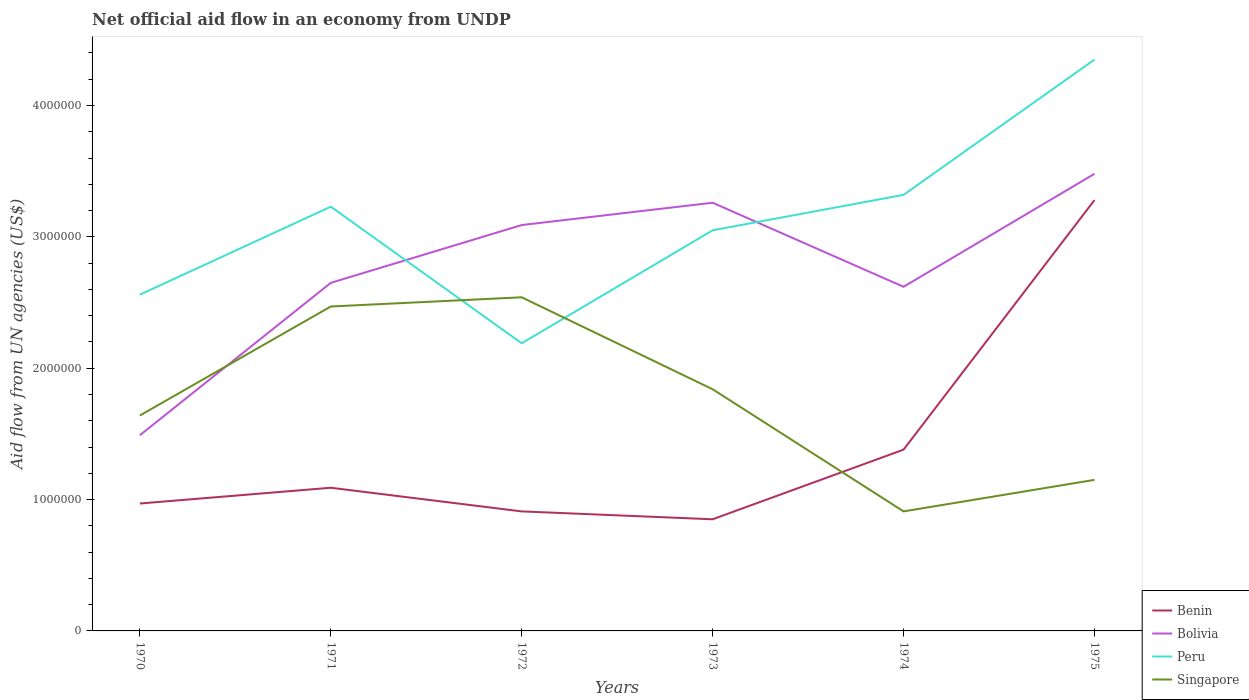How many different coloured lines are there?
Your answer should be very brief. 4. Across all years, what is the maximum net official aid flow in Bolivia?
Give a very brief answer. 1.49e+06. In which year was the net official aid flow in Singapore maximum?
Provide a succinct answer. 1974. What is the total net official aid flow in Benin in the graph?
Your response must be concise. -2.43e+06. What is the difference between the highest and the second highest net official aid flow in Benin?
Your answer should be very brief. 2.43e+06. Is the net official aid flow in Bolivia strictly greater than the net official aid flow in Benin over the years?
Provide a short and direct response. No. How many lines are there?
Make the answer very short. 4. How many years are there in the graph?
Offer a terse response. 6. What is the difference between two consecutive major ticks on the Y-axis?
Offer a very short reply. 1.00e+06. Does the graph contain grids?
Your answer should be compact. No. Where does the legend appear in the graph?
Your answer should be very brief. Bottom right. How are the legend labels stacked?
Offer a very short reply. Vertical. What is the title of the graph?
Your answer should be compact. Net official aid flow in an economy from UNDP. What is the label or title of the X-axis?
Ensure brevity in your answer.  Years. What is the label or title of the Y-axis?
Provide a succinct answer. Aid flow from UN agencies (US$). What is the Aid flow from UN agencies (US$) of Benin in 1970?
Make the answer very short. 9.70e+05. What is the Aid flow from UN agencies (US$) of Bolivia in 1970?
Offer a very short reply. 1.49e+06. What is the Aid flow from UN agencies (US$) of Peru in 1970?
Provide a succinct answer. 2.56e+06. What is the Aid flow from UN agencies (US$) of Singapore in 1970?
Offer a terse response. 1.64e+06. What is the Aid flow from UN agencies (US$) of Benin in 1971?
Your response must be concise. 1.09e+06. What is the Aid flow from UN agencies (US$) in Bolivia in 1971?
Ensure brevity in your answer.  2.65e+06. What is the Aid flow from UN agencies (US$) in Peru in 1971?
Your answer should be compact. 3.23e+06. What is the Aid flow from UN agencies (US$) of Singapore in 1971?
Ensure brevity in your answer.  2.47e+06. What is the Aid flow from UN agencies (US$) of Benin in 1972?
Your answer should be very brief. 9.10e+05. What is the Aid flow from UN agencies (US$) in Bolivia in 1972?
Offer a very short reply. 3.09e+06. What is the Aid flow from UN agencies (US$) in Peru in 1972?
Your answer should be compact. 2.19e+06. What is the Aid flow from UN agencies (US$) of Singapore in 1972?
Give a very brief answer. 2.54e+06. What is the Aid flow from UN agencies (US$) of Benin in 1973?
Your answer should be compact. 8.50e+05. What is the Aid flow from UN agencies (US$) of Bolivia in 1973?
Make the answer very short. 3.26e+06. What is the Aid flow from UN agencies (US$) in Peru in 1973?
Your answer should be very brief. 3.05e+06. What is the Aid flow from UN agencies (US$) in Singapore in 1973?
Make the answer very short. 1.84e+06. What is the Aid flow from UN agencies (US$) in Benin in 1974?
Keep it short and to the point. 1.38e+06. What is the Aid flow from UN agencies (US$) in Bolivia in 1974?
Keep it short and to the point. 2.62e+06. What is the Aid flow from UN agencies (US$) in Peru in 1974?
Your response must be concise. 3.32e+06. What is the Aid flow from UN agencies (US$) in Singapore in 1974?
Your response must be concise. 9.10e+05. What is the Aid flow from UN agencies (US$) of Benin in 1975?
Provide a short and direct response. 3.28e+06. What is the Aid flow from UN agencies (US$) in Bolivia in 1975?
Keep it short and to the point. 3.48e+06. What is the Aid flow from UN agencies (US$) of Peru in 1975?
Provide a succinct answer. 4.35e+06. What is the Aid flow from UN agencies (US$) in Singapore in 1975?
Make the answer very short. 1.15e+06. Across all years, what is the maximum Aid flow from UN agencies (US$) in Benin?
Keep it short and to the point. 3.28e+06. Across all years, what is the maximum Aid flow from UN agencies (US$) of Bolivia?
Ensure brevity in your answer.  3.48e+06. Across all years, what is the maximum Aid flow from UN agencies (US$) of Peru?
Ensure brevity in your answer.  4.35e+06. Across all years, what is the maximum Aid flow from UN agencies (US$) in Singapore?
Your response must be concise. 2.54e+06. Across all years, what is the minimum Aid flow from UN agencies (US$) of Benin?
Provide a succinct answer. 8.50e+05. Across all years, what is the minimum Aid flow from UN agencies (US$) in Bolivia?
Provide a short and direct response. 1.49e+06. Across all years, what is the minimum Aid flow from UN agencies (US$) of Peru?
Ensure brevity in your answer.  2.19e+06. Across all years, what is the minimum Aid flow from UN agencies (US$) in Singapore?
Give a very brief answer. 9.10e+05. What is the total Aid flow from UN agencies (US$) of Benin in the graph?
Provide a short and direct response. 8.48e+06. What is the total Aid flow from UN agencies (US$) in Bolivia in the graph?
Ensure brevity in your answer.  1.66e+07. What is the total Aid flow from UN agencies (US$) of Peru in the graph?
Offer a very short reply. 1.87e+07. What is the total Aid flow from UN agencies (US$) in Singapore in the graph?
Your answer should be compact. 1.06e+07. What is the difference between the Aid flow from UN agencies (US$) in Bolivia in 1970 and that in 1971?
Provide a short and direct response. -1.16e+06. What is the difference between the Aid flow from UN agencies (US$) of Peru in 1970 and that in 1971?
Provide a short and direct response. -6.70e+05. What is the difference between the Aid flow from UN agencies (US$) in Singapore in 1970 and that in 1971?
Offer a terse response. -8.30e+05. What is the difference between the Aid flow from UN agencies (US$) in Benin in 1970 and that in 1972?
Your answer should be compact. 6.00e+04. What is the difference between the Aid flow from UN agencies (US$) of Bolivia in 1970 and that in 1972?
Keep it short and to the point. -1.60e+06. What is the difference between the Aid flow from UN agencies (US$) of Peru in 1970 and that in 1972?
Ensure brevity in your answer.  3.70e+05. What is the difference between the Aid flow from UN agencies (US$) in Singapore in 1970 and that in 1972?
Offer a very short reply. -9.00e+05. What is the difference between the Aid flow from UN agencies (US$) of Benin in 1970 and that in 1973?
Keep it short and to the point. 1.20e+05. What is the difference between the Aid flow from UN agencies (US$) in Bolivia in 1970 and that in 1973?
Make the answer very short. -1.77e+06. What is the difference between the Aid flow from UN agencies (US$) of Peru in 1970 and that in 1973?
Give a very brief answer. -4.90e+05. What is the difference between the Aid flow from UN agencies (US$) in Singapore in 1970 and that in 1973?
Your answer should be compact. -2.00e+05. What is the difference between the Aid flow from UN agencies (US$) in Benin in 1970 and that in 1974?
Offer a very short reply. -4.10e+05. What is the difference between the Aid flow from UN agencies (US$) in Bolivia in 1970 and that in 1974?
Your answer should be very brief. -1.13e+06. What is the difference between the Aid flow from UN agencies (US$) of Peru in 1970 and that in 1974?
Your response must be concise. -7.60e+05. What is the difference between the Aid flow from UN agencies (US$) in Singapore in 1970 and that in 1974?
Your answer should be very brief. 7.30e+05. What is the difference between the Aid flow from UN agencies (US$) of Benin in 1970 and that in 1975?
Give a very brief answer. -2.31e+06. What is the difference between the Aid flow from UN agencies (US$) of Bolivia in 1970 and that in 1975?
Give a very brief answer. -1.99e+06. What is the difference between the Aid flow from UN agencies (US$) of Peru in 1970 and that in 1975?
Make the answer very short. -1.79e+06. What is the difference between the Aid flow from UN agencies (US$) of Benin in 1971 and that in 1972?
Your answer should be compact. 1.80e+05. What is the difference between the Aid flow from UN agencies (US$) of Bolivia in 1971 and that in 1972?
Provide a short and direct response. -4.40e+05. What is the difference between the Aid flow from UN agencies (US$) in Peru in 1971 and that in 1972?
Offer a very short reply. 1.04e+06. What is the difference between the Aid flow from UN agencies (US$) in Singapore in 1971 and that in 1972?
Your response must be concise. -7.00e+04. What is the difference between the Aid flow from UN agencies (US$) of Bolivia in 1971 and that in 1973?
Offer a very short reply. -6.10e+05. What is the difference between the Aid flow from UN agencies (US$) of Singapore in 1971 and that in 1973?
Your answer should be very brief. 6.30e+05. What is the difference between the Aid flow from UN agencies (US$) in Bolivia in 1971 and that in 1974?
Provide a short and direct response. 3.00e+04. What is the difference between the Aid flow from UN agencies (US$) of Peru in 1971 and that in 1974?
Provide a short and direct response. -9.00e+04. What is the difference between the Aid flow from UN agencies (US$) of Singapore in 1971 and that in 1974?
Provide a succinct answer. 1.56e+06. What is the difference between the Aid flow from UN agencies (US$) in Benin in 1971 and that in 1975?
Provide a short and direct response. -2.19e+06. What is the difference between the Aid flow from UN agencies (US$) of Bolivia in 1971 and that in 1975?
Your response must be concise. -8.30e+05. What is the difference between the Aid flow from UN agencies (US$) in Peru in 1971 and that in 1975?
Provide a succinct answer. -1.12e+06. What is the difference between the Aid flow from UN agencies (US$) of Singapore in 1971 and that in 1975?
Give a very brief answer. 1.32e+06. What is the difference between the Aid flow from UN agencies (US$) of Benin in 1972 and that in 1973?
Make the answer very short. 6.00e+04. What is the difference between the Aid flow from UN agencies (US$) in Bolivia in 1972 and that in 1973?
Your answer should be compact. -1.70e+05. What is the difference between the Aid flow from UN agencies (US$) in Peru in 1972 and that in 1973?
Offer a terse response. -8.60e+05. What is the difference between the Aid flow from UN agencies (US$) of Benin in 1972 and that in 1974?
Provide a succinct answer. -4.70e+05. What is the difference between the Aid flow from UN agencies (US$) of Bolivia in 1972 and that in 1974?
Provide a short and direct response. 4.70e+05. What is the difference between the Aid flow from UN agencies (US$) of Peru in 1972 and that in 1974?
Provide a short and direct response. -1.13e+06. What is the difference between the Aid flow from UN agencies (US$) in Singapore in 1972 and that in 1974?
Make the answer very short. 1.63e+06. What is the difference between the Aid flow from UN agencies (US$) of Benin in 1972 and that in 1975?
Provide a succinct answer. -2.37e+06. What is the difference between the Aid flow from UN agencies (US$) of Bolivia in 1972 and that in 1975?
Provide a short and direct response. -3.90e+05. What is the difference between the Aid flow from UN agencies (US$) of Peru in 1972 and that in 1975?
Give a very brief answer. -2.16e+06. What is the difference between the Aid flow from UN agencies (US$) in Singapore in 1972 and that in 1975?
Keep it short and to the point. 1.39e+06. What is the difference between the Aid flow from UN agencies (US$) in Benin in 1973 and that in 1974?
Ensure brevity in your answer.  -5.30e+05. What is the difference between the Aid flow from UN agencies (US$) of Bolivia in 1973 and that in 1974?
Keep it short and to the point. 6.40e+05. What is the difference between the Aid flow from UN agencies (US$) of Peru in 1973 and that in 1974?
Provide a succinct answer. -2.70e+05. What is the difference between the Aid flow from UN agencies (US$) in Singapore in 1973 and that in 1974?
Ensure brevity in your answer.  9.30e+05. What is the difference between the Aid flow from UN agencies (US$) of Benin in 1973 and that in 1975?
Offer a very short reply. -2.43e+06. What is the difference between the Aid flow from UN agencies (US$) in Bolivia in 1973 and that in 1975?
Keep it short and to the point. -2.20e+05. What is the difference between the Aid flow from UN agencies (US$) in Peru in 1973 and that in 1975?
Your answer should be very brief. -1.30e+06. What is the difference between the Aid flow from UN agencies (US$) in Singapore in 1973 and that in 1975?
Offer a very short reply. 6.90e+05. What is the difference between the Aid flow from UN agencies (US$) in Benin in 1974 and that in 1975?
Your answer should be compact. -1.90e+06. What is the difference between the Aid flow from UN agencies (US$) of Bolivia in 1974 and that in 1975?
Ensure brevity in your answer.  -8.60e+05. What is the difference between the Aid flow from UN agencies (US$) of Peru in 1974 and that in 1975?
Ensure brevity in your answer.  -1.03e+06. What is the difference between the Aid flow from UN agencies (US$) in Singapore in 1974 and that in 1975?
Your answer should be compact. -2.40e+05. What is the difference between the Aid flow from UN agencies (US$) of Benin in 1970 and the Aid flow from UN agencies (US$) of Bolivia in 1971?
Your answer should be very brief. -1.68e+06. What is the difference between the Aid flow from UN agencies (US$) of Benin in 1970 and the Aid flow from UN agencies (US$) of Peru in 1971?
Offer a terse response. -2.26e+06. What is the difference between the Aid flow from UN agencies (US$) of Benin in 1970 and the Aid flow from UN agencies (US$) of Singapore in 1971?
Your response must be concise. -1.50e+06. What is the difference between the Aid flow from UN agencies (US$) in Bolivia in 1970 and the Aid flow from UN agencies (US$) in Peru in 1971?
Offer a very short reply. -1.74e+06. What is the difference between the Aid flow from UN agencies (US$) of Bolivia in 1970 and the Aid flow from UN agencies (US$) of Singapore in 1971?
Your answer should be very brief. -9.80e+05. What is the difference between the Aid flow from UN agencies (US$) in Benin in 1970 and the Aid flow from UN agencies (US$) in Bolivia in 1972?
Offer a very short reply. -2.12e+06. What is the difference between the Aid flow from UN agencies (US$) in Benin in 1970 and the Aid flow from UN agencies (US$) in Peru in 1972?
Offer a terse response. -1.22e+06. What is the difference between the Aid flow from UN agencies (US$) of Benin in 1970 and the Aid flow from UN agencies (US$) of Singapore in 1972?
Your answer should be compact. -1.57e+06. What is the difference between the Aid flow from UN agencies (US$) of Bolivia in 1970 and the Aid flow from UN agencies (US$) of Peru in 1972?
Your response must be concise. -7.00e+05. What is the difference between the Aid flow from UN agencies (US$) of Bolivia in 1970 and the Aid flow from UN agencies (US$) of Singapore in 1972?
Give a very brief answer. -1.05e+06. What is the difference between the Aid flow from UN agencies (US$) of Benin in 1970 and the Aid flow from UN agencies (US$) of Bolivia in 1973?
Keep it short and to the point. -2.29e+06. What is the difference between the Aid flow from UN agencies (US$) in Benin in 1970 and the Aid flow from UN agencies (US$) in Peru in 1973?
Your answer should be compact. -2.08e+06. What is the difference between the Aid flow from UN agencies (US$) of Benin in 1970 and the Aid flow from UN agencies (US$) of Singapore in 1973?
Offer a very short reply. -8.70e+05. What is the difference between the Aid flow from UN agencies (US$) in Bolivia in 1970 and the Aid flow from UN agencies (US$) in Peru in 1973?
Make the answer very short. -1.56e+06. What is the difference between the Aid flow from UN agencies (US$) in Bolivia in 1970 and the Aid flow from UN agencies (US$) in Singapore in 1973?
Your answer should be compact. -3.50e+05. What is the difference between the Aid flow from UN agencies (US$) of Peru in 1970 and the Aid flow from UN agencies (US$) of Singapore in 1973?
Ensure brevity in your answer.  7.20e+05. What is the difference between the Aid flow from UN agencies (US$) of Benin in 1970 and the Aid flow from UN agencies (US$) of Bolivia in 1974?
Your response must be concise. -1.65e+06. What is the difference between the Aid flow from UN agencies (US$) of Benin in 1970 and the Aid flow from UN agencies (US$) of Peru in 1974?
Your answer should be very brief. -2.35e+06. What is the difference between the Aid flow from UN agencies (US$) in Benin in 1970 and the Aid flow from UN agencies (US$) in Singapore in 1974?
Ensure brevity in your answer.  6.00e+04. What is the difference between the Aid flow from UN agencies (US$) in Bolivia in 1970 and the Aid flow from UN agencies (US$) in Peru in 1974?
Your answer should be compact. -1.83e+06. What is the difference between the Aid flow from UN agencies (US$) in Bolivia in 1970 and the Aid flow from UN agencies (US$) in Singapore in 1974?
Offer a very short reply. 5.80e+05. What is the difference between the Aid flow from UN agencies (US$) in Peru in 1970 and the Aid flow from UN agencies (US$) in Singapore in 1974?
Offer a very short reply. 1.65e+06. What is the difference between the Aid flow from UN agencies (US$) in Benin in 1970 and the Aid flow from UN agencies (US$) in Bolivia in 1975?
Provide a succinct answer. -2.51e+06. What is the difference between the Aid flow from UN agencies (US$) in Benin in 1970 and the Aid flow from UN agencies (US$) in Peru in 1975?
Provide a succinct answer. -3.38e+06. What is the difference between the Aid flow from UN agencies (US$) in Benin in 1970 and the Aid flow from UN agencies (US$) in Singapore in 1975?
Offer a very short reply. -1.80e+05. What is the difference between the Aid flow from UN agencies (US$) of Bolivia in 1970 and the Aid flow from UN agencies (US$) of Peru in 1975?
Your answer should be very brief. -2.86e+06. What is the difference between the Aid flow from UN agencies (US$) of Peru in 1970 and the Aid flow from UN agencies (US$) of Singapore in 1975?
Keep it short and to the point. 1.41e+06. What is the difference between the Aid flow from UN agencies (US$) in Benin in 1971 and the Aid flow from UN agencies (US$) in Bolivia in 1972?
Your response must be concise. -2.00e+06. What is the difference between the Aid flow from UN agencies (US$) in Benin in 1971 and the Aid flow from UN agencies (US$) in Peru in 1972?
Keep it short and to the point. -1.10e+06. What is the difference between the Aid flow from UN agencies (US$) of Benin in 1971 and the Aid flow from UN agencies (US$) of Singapore in 1972?
Make the answer very short. -1.45e+06. What is the difference between the Aid flow from UN agencies (US$) in Bolivia in 1971 and the Aid flow from UN agencies (US$) in Singapore in 1972?
Your answer should be very brief. 1.10e+05. What is the difference between the Aid flow from UN agencies (US$) of Peru in 1971 and the Aid flow from UN agencies (US$) of Singapore in 1972?
Ensure brevity in your answer.  6.90e+05. What is the difference between the Aid flow from UN agencies (US$) of Benin in 1971 and the Aid flow from UN agencies (US$) of Bolivia in 1973?
Provide a short and direct response. -2.17e+06. What is the difference between the Aid flow from UN agencies (US$) of Benin in 1971 and the Aid flow from UN agencies (US$) of Peru in 1973?
Ensure brevity in your answer.  -1.96e+06. What is the difference between the Aid flow from UN agencies (US$) of Benin in 1971 and the Aid flow from UN agencies (US$) of Singapore in 1973?
Give a very brief answer. -7.50e+05. What is the difference between the Aid flow from UN agencies (US$) of Bolivia in 1971 and the Aid flow from UN agencies (US$) of Peru in 1973?
Offer a very short reply. -4.00e+05. What is the difference between the Aid flow from UN agencies (US$) of Bolivia in 1971 and the Aid flow from UN agencies (US$) of Singapore in 1973?
Your answer should be very brief. 8.10e+05. What is the difference between the Aid flow from UN agencies (US$) of Peru in 1971 and the Aid flow from UN agencies (US$) of Singapore in 1973?
Provide a succinct answer. 1.39e+06. What is the difference between the Aid flow from UN agencies (US$) in Benin in 1971 and the Aid flow from UN agencies (US$) in Bolivia in 1974?
Provide a succinct answer. -1.53e+06. What is the difference between the Aid flow from UN agencies (US$) of Benin in 1971 and the Aid flow from UN agencies (US$) of Peru in 1974?
Your response must be concise. -2.23e+06. What is the difference between the Aid flow from UN agencies (US$) in Benin in 1971 and the Aid flow from UN agencies (US$) in Singapore in 1974?
Your answer should be very brief. 1.80e+05. What is the difference between the Aid flow from UN agencies (US$) in Bolivia in 1971 and the Aid flow from UN agencies (US$) in Peru in 1974?
Provide a succinct answer. -6.70e+05. What is the difference between the Aid flow from UN agencies (US$) in Bolivia in 1971 and the Aid flow from UN agencies (US$) in Singapore in 1974?
Your response must be concise. 1.74e+06. What is the difference between the Aid flow from UN agencies (US$) in Peru in 1971 and the Aid flow from UN agencies (US$) in Singapore in 1974?
Give a very brief answer. 2.32e+06. What is the difference between the Aid flow from UN agencies (US$) of Benin in 1971 and the Aid flow from UN agencies (US$) of Bolivia in 1975?
Offer a terse response. -2.39e+06. What is the difference between the Aid flow from UN agencies (US$) of Benin in 1971 and the Aid flow from UN agencies (US$) of Peru in 1975?
Your answer should be compact. -3.26e+06. What is the difference between the Aid flow from UN agencies (US$) in Benin in 1971 and the Aid flow from UN agencies (US$) in Singapore in 1975?
Your response must be concise. -6.00e+04. What is the difference between the Aid flow from UN agencies (US$) of Bolivia in 1971 and the Aid flow from UN agencies (US$) of Peru in 1975?
Your answer should be very brief. -1.70e+06. What is the difference between the Aid flow from UN agencies (US$) in Bolivia in 1971 and the Aid flow from UN agencies (US$) in Singapore in 1975?
Your response must be concise. 1.50e+06. What is the difference between the Aid flow from UN agencies (US$) in Peru in 1971 and the Aid flow from UN agencies (US$) in Singapore in 1975?
Keep it short and to the point. 2.08e+06. What is the difference between the Aid flow from UN agencies (US$) of Benin in 1972 and the Aid flow from UN agencies (US$) of Bolivia in 1973?
Give a very brief answer. -2.35e+06. What is the difference between the Aid flow from UN agencies (US$) of Benin in 1972 and the Aid flow from UN agencies (US$) of Peru in 1973?
Give a very brief answer. -2.14e+06. What is the difference between the Aid flow from UN agencies (US$) in Benin in 1972 and the Aid flow from UN agencies (US$) in Singapore in 1973?
Your answer should be compact. -9.30e+05. What is the difference between the Aid flow from UN agencies (US$) of Bolivia in 1972 and the Aid flow from UN agencies (US$) of Peru in 1973?
Keep it short and to the point. 4.00e+04. What is the difference between the Aid flow from UN agencies (US$) in Bolivia in 1972 and the Aid flow from UN agencies (US$) in Singapore in 1973?
Your answer should be compact. 1.25e+06. What is the difference between the Aid flow from UN agencies (US$) in Benin in 1972 and the Aid flow from UN agencies (US$) in Bolivia in 1974?
Keep it short and to the point. -1.71e+06. What is the difference between the Aid flow from UN agencies (US$) in Benin in 1972 and the Aid flow from UN agencies (US$) in Peru in 1974?
Offer a very short reply. -2.41e+06. What is the difference between the Aid flow from UN agencies (US$) in Benin in 1972 and the Aid flow from UN agencies (US$) in Singapore in 1974?
Your answer should be very brief. 0. What is the difference between the Aid flow from UN agencies (US$) in Bolivia in 1972 and the Aid flow from UN agencies (US$) in Peru in 1974?
Keep it short and to the point. -2.30e+05. What is the difference between the Aid flow from UN agencies (US$) in Bolivia in 1972 and the Aid flow from UN agencies (US$) in Singapore in 1974?
Ensure brevity in your answer.  2.18e+06. What is the difference between the Aid flow from UN agencies (US$) in Peru in 1972 and the Aid flow from UN agencies (US$) in Singapore in 1974?
Ensure brevity in your answer.  1.28e+06. What is the difference between the Aid flow from UN agencies (US$) of Benin in 1972 and the Aid flow from UN agencies (US$) of Bolivia in 1975?
Your response must be concise. -2.57e+06. What is the difference between the Aid flow from UN agencies (US$) of Benin in 1972 and the Aid flow from UN agencies (US$) of Peru in 1975?
Provide a short and direct response. -3.44e+06. What is the difference between the Aid flow from UN agencies (US$) of Benin in 1972 and the Aid flow from UN agencies (US$) of Singapore in 1975?
Offer a very short reply. -2.40e+05. What is the difference between the Aid flow from UN agencies (US$) of Bolivia in 1972 and the Aid flow from UN agencies (US$) of Peru in 1975?
Keep it short and to the point. -1.26e+06. What is the difference between the Aid flow from UN agencies (US$) in Bolivia in 1972 and the Aid flow from UN agencies (US$) in Singapore in 1975?
Your answer should be very brief. 1.94e+06. What is the difference between the Aid flow from UN agencies (US$) in Peru in 1972 and the Aid flow from UN agencies (US$) in Singapore in 1975?
Provide a succinct answer. 1.04e+06. What is the difference between the Aid flow from UN agencies (US$) in Benin in 1973 and the Aid flow from UN agencies (US$) in Bolivia in 1974?
Offer a terse response. -1.77e+06. What is the difference between the Aid flow from UN agencies (US$) in Benin in 1973 and the Aid flow from UN agencies (US$) in Peru in 1974?
Offer a terse response. -2.47e+06. What is the difference between the Aid flow from UN agencies (US$) of Benin in 1973 and the Aid flow from UN agencies (US$) of Singapore in 1974?
Make the answer very short. -6.00e+04. What is the difference between the Aid flow from UN agencies (US$) of Bolivia in 1973 and the Aid flow from UN agencies (US$) of Singapore in 1974?
Keep it short and to the point. 2.35e+06. What is the difference between the Aid flow from UN agencies (US$) in Peru in 1973 and the Aid flow from UN agencies (US$) in Singapore in 1974?
Your answer should be very brief. 2.14e+06. What is the difference between the Aid flow from UN agencies (US$) of Benin in 1973 and the Aid flow from UN agencies (US$) of Bolivia in 1975?
Your response must be concise. -2.63e+06. What is the difference between the Aid flow from UN agencies (US$) of Benin in 1973 and the Aid flow from UN agencies (US$) of Peru in 1975?
Provide a succinct answer. -3.50e+06. What is the difference between the Aid flow from UN agencies (US$) in Bolivia in 1973 and the Aid flow from UN agencies (US$) in Peru in 1975?
Provide a succinct answer. -1.09e+06. What is the difference between the Aid flow from UN agencies (US$) of Bolivia in 1973 and the Aid flow from UN agencies (US$) of Singapore in 1975?
Your response must be concise. 2.11e+06. What is the difference between the Aid flow from UN agencies (US$) of Peru in 1973 and the Aid flow from UN agencies (US$) of Singapore in 1975?
Offer a very short reply. 1.90e+06. What is the difference between the Aid flow from UN agencies (US$) of Benin in 1974 and the Aid flow from UN agencies (US$) of Bolivia in 1975?
Offer a terse response. -2.10e+06. What is the difference between the Aid flow from UN agencies (US$) in Benin in 1974 and the Aid flow from UN agencies (US$) in Peru in 1975?
Your response must be concise. -2.97e+06. What is the difference between the Aid flow from UN agencies (US$) in Bolivia in 1974 and the Aid flow from UN agencies (US$) in Peru in 1975?
Your response must be concise. -1.73e+06. What is the difference between the Aid flow from UN agencies (US$) of Bolivia in 1974 and the Aid flow from UN agencies (US$) of Singapore in 1975?
Provide a short and direct response. 1.47e+06. What is the difference between the Aid flow from UN agencies (US$) of Peru in 1974 and the Aid flow from UN agencies (US$) of Singapore in 1975?
Your response must be concise. 2.17e+06. What is the average Aid flow from UN agencies (US$) in Benin per year?
Keep it short and to the point. 1.41e+06. What is the average Aid flow from UN agencies (US$) of Bolivia per year?
Offer a terse response. 2.76e+06. What is the average Aid flow from UN agencies (US$) in Peru per year?
Your response must be concise. 3.12e+06. What is the average Aid flow from UN agencies (US$) in Singapore per year?
Give a very brief answer. 1.76e+06. In the year 1970, what is the difference between the Aid flow from UN agencies (US$) in Benin and Aid flow from UN agencies (US$) in Bolivia?
Your response must be concise. -5.20e+05. In the year 1970, what is the difference between the Aid flow from UN agencies (US$) of Benin and Aid flow from UN agencies (US$) of Peru?
Your answer should be very brief. -1.59e+06. In the year 1970, what is the difference between the Aid flow from UN agencies (US$) of Benin and Aid flow from UN agencies (US$) of Singapore?
Provide a succinct answer. -6.70e+05. In the year 1970, what is the difference between the Aid flow from UN agencies (US$) of Bolivia and Aid flow from UN agencies (US$) of Peru?
Offer a very short reply. -1.07e+06. In the year 1970, what is the difference between the Aid flow from UN agencies (US$) in Peru and Aid flow from UN agencies (US$) in Singapore?
Your answer should be very brief. 9.20e+05. In the year 1971, what is the difference between the Aid flow from UN agencies (US$) of Benin and Aid flow from UN agencies (US$) of Bolivia?
Offer a terse response. -1.56e+06. In the year 1971, what is the difference between the Aid flow from UN agencies (US$) of Benin and Aid flow from UN agencies (US$) of Peru?
Ensure brevity in your answer.  -2.14e+06. In the year 1971, what is the difference between the Aid flow from UN agencies (US$) in Benin and Aid flow from UN agencies (US$) in Singapore?
Provide a short and direct response. -1.38e+06. In the year 1971, what is the difference between the Aid flow from UN agencies (US$) of Bolivia and Aid flow from UN agencies (US$) of Peru?
Your answer should be very brief. -5.80e+05. In the year 1971, what is the difference between the Aid flow from UN agencies (US$) of Peru and Aid flow from UN agencies (US$) of Singapore?
Make the answer very short. 7.60e+05. In the year 1972, what is the difference between the Aid flow from UN agencies (US$) of Benin and Aid flow from UN agencies (US$) of Bolivia?
Provide a succinct answer. -2.18e+06. In the year 1972, what is the difference between the Aid flow from UN agencies (US$) in Benin and Aid flow from UN agencies (US$) in Peru?
Make the answer very short. -1.28e+06. In the year 1972, what is the difference between the Aid flow from UN agencies (US$) in Benin and Aid flow from UN agencies (US$) in Singapore?
Ensure brevity in your answer.  -1.63e+06. In the year 1972, what is the difference between the Aid flow from UN agencies (US$) of Bolivia and Aid flow from UN agencies (US$) of Singapore?
Give a very brief answer. 5.50e+05. In the year 1972, what is the difference between the Aid flow from UN agencies (US$) in Peru and Aid flow from UN agencies (US$) in Singapore?
Ensure brevity in your answer.  -3.50e+05. In the year 1973, what is the difference between the Aid flow from UN agencies (US$) in Benin and Aid flow from UN agencies (US$) in Bolivia?
Ensure brevity in your answer.  -2.41e+06. In the year 1973, what is the difference between the Aid flow from UN agencies (US$) of Benin and Aid flow from UN agencies (US$) of Peru?
Provide a short and direct response. -2.20e+06. In the year 1973, what is the difference between the Aid flow from UN agencies (US$) in Benin and Aid flow from UN agencies (US$) in Singapore?
Provide a short and direct response. -9.90e+05. In the year 1973, what is the difference between the Aid flow from UN agencies (US$) of Bolivia and Aid flow from UN agencies (US$) of Peru?
Your response must be concise. 2.10e+05. In the year 1973, what is the difference between the Aid flow from UN agencies (US$) of Bolivia and Aid flow from UN agencies (US$) of Singapore?
Provide a short and direct response. 1.42e+06. In the year 1973, what is the difference between the Aid flow from UN agencies (US$) of Peru and Aid flow from UN agencies (US$) of Singapore?
Provide a short and direct response. 1.21e+06. In the year 1974, what is the difference between the Aid flow from UN agencies (US$) of Benin and Aid flow from UN agencies (US$) of Bolivia?
Your response must be concise. -1.24e+06. In the year 1974, what is the difference between the Aid flow from UN agencies (US$) of Benin and Aid flow from UN agencies (US$) of Peru?
Ensure brevity in your answer.  -1.94e+06. In the year 1974, what is the difference between the Aid flow from UN agencies (US$) in Bolivia and Aid flow from UN agencies (US$) in Peru?
Give a very brief answer. -7.00e+05. In the year 1974, what is the difference between the Aid flow from UN agencies (US$) of Bolivia and Aid flow from UN agencies (US$) of Singapore?
Ensure brevity in your answer.  1.71e+06. In the year 1974, what is the difference between the Aid flow from UN agencies (US$) in Peru and Aid flow from UN agencies (US$) in Singapore?
Ensure brevity in your answer.  2.41e+06. In the year 1975, what is the difference between the Aid flow from UN agencies (US$) in Benin and Aid flow from UN agencies (US$) in Bolivia?
Provide a succinct answer. -2.00e+05. In the year 1975, what is the difference between the Aid flow from UN agencies (US$) in Benin and Aid flow from UN agencies (US$) in Peru?
Ensure brevity in your answer.  -1.07e+06. In the year 1975, what is the difference between the Aid flow from UN agencies (US$) in Benin and Aid flow from UN agencies (US$) in Singapore?
Your answer should be compact. 2.13e+06. In the year 1975, what is the difference between the Aid flow from UN agencies (US$) in Bolivia and Aid flow from UN agencies (US$) in Peru?
Keep it short and to the point. -8.70e+05. In the year 1975, what is the difference between the Aid flow from UN agencies (US$) in Bolivia and Aid flow from UN agencies (US$) in Singapore?
Provide a succinct answer. 2.33e+06. In the year 1975, what is the difference between the Aid flow from UN agencies (US$) of Peru and Aid flow from UN agencies (US$) of Singapore?
Your response must be concise. 3.20e+06. What is the ratio of the Aid flow from UN agencies (US$) of Benin in 1970 to that in 1971?
Your response must be concise. 0.89. What is the ratio of the Aid flow from UN agencies (US$) of Bolivia in 1970 to that in 1971?
Provide a succinct answer. 0.56. What is the ratio of the Aid flow from UN agencies (US$) of Peru in 1970 to that in 1971?
Offer a terse response. 0.79. What is the ratio of the Aid flow from UN agencies (US$) of Singapore in 1970 to that in 1971?
Provide a succinct answer. 0.66. What is the ratio of the Aid flow from UN agencies (US$) of Benin in 1970 to that in 1972?
Offer a very short reply. 1.07. What is the ratio of the Aid flow from UN agencies (US$) of Bolivia in 1970 to that in 1972?
Provide a short and direct response. 0.48. What is the ratio of the Aid flow from UN agencies (US$) in Peru in 1970 to that in 1972?
Your answer should be very brief. 1.17. What is the ratio of the Aid flow from UN agencies (US$) in Singapore in 1970 to that in 1972?
Offer a very short reply. 0.65. What is the ratio of the Aid flow from UN agencies (US$) in Benin in 1970 to that in 1973?
Offer a very short reply. 1.14. What is the ratio of the Aid flow from UN agencies (US$) of Bolivia in 1970 to that in 1973?
Ensure brevity in your answer.  0.46. What is the ratio of the Aid flow from UN agencies (US$) in Peru in 1970 to that in 1973?
Provide a short and direct response. 0.84. What is the ratio of the Aid flow from UN agencies (US$) of Singapore in 1970 to that in 1973?
Provide a short and direct response. 0.89. What is the ratio of the Aid flow from UN agencies (US$) in Benin in 1970 to that in 1974?
Provide a short and direct response. 0.7. What is the ratio of the Aid flow from UN agencies (US$) of Bolivia in 1970 to that in 1974?
Offer a terse response. 0.57. What is the ratio of the Aid flow from UN agencies (US$) in Peru in 1970 to that in 1974?
Provide a short and direct response. 0.77. What is the ratio of the Aid flow from UN agencies (US$) in Singapore in 1970 to that in 1974?
Give a very brief answer. 1.8. What is the ratio of the Aid flow from UN agencies (US$) of Benin in 1970 to that in 1975?
Your answer should be compact. 0.3. What is the ratio of the Aid flow from UN agencies (US$) of Bolivia in 1970 to that in 1975?
Your response must be concise. 0.43. What is the ratio of the Aid flow from UN agencies (US$) of Peru in 1970 to that in 1975?
Give a very brief answer. 0.59. What is the ratio of the Aid flow from UN agencies (US$) of Singapore in 1970 to that in 1975?
Provide a succinct answer. 1.43. What is the ratio of the Aid flow from UN agencies (US$) in Benin in 1971 to that in 1972?
Ensure brevity in your answer.  1.2. What is the ratio of the Aid flow from UN agencies (US$) of Bolivia in 1971 to that in 1972?
Provide a succinct answer. 0.86. What is the ratio of the Aid flow from UN agencies (US$) of Peru in 1971 to that in 1972?
Provide a succinct answer. 1.47. What is the ratio of the Aid flow from UN agencies (US$) in Singapore in 1971 to that in 1972?
Offer a terse response. 0.97. What is the ratio of the Aid flow from UN agencies (US$) in Benin in 1971 to that in 1973?
Your answer should be compact. 1.28. What is the ratio of the Aid flow from UN agencies (US$) in Bolivia in 1971 to that in 1973?
Make the answer very short. 0.81. What is the ratio of the Aid flow from UN agencies (US$) in Peru in 1971 to that in 1973?
Your response must be concise. 1.06. What is the ratio of the Aid flow from UN agencies (US$) of Singapore in 1971 to that in 1973?
Your answer should be compact. 1.34. What is the ratio of the Aid flow from UN agencies (US$) in Benin in 1971 to that in 1974?
Provide a short and direct response. 0.79. What is the ratio of the Aid flow from UN agencies (US$) in Bolivia in 1971 to that in 1974?
Offer a terse response. 1.01. What is the ratio of the Aid flow from UN agencies (US$) in Peru in 1971 to that in 1974?
Provide a succinct answer. 0.97. What is the ratio of the Aid flow from UN agencies (US$) in Singapore in 1971 to that in 1974?
Provide a short and direct response. 2.71. What is the ratio of the Aid flow from UN agencies (US$) of Benin in 1971 to that in 1975?
Your answer should be compact. 0.33. What is the ratio of the Aid flow from UN agencies (US$) of Bolivia in 1971 to that in 1975?
Provide a short and direct response. 0.76. What is the ratio of the Aid flow from UN agencies (US$) in Peru in 1971 to that in 1975?
Keep it short and to the point. 0.74. What is the ratio of the Aid flow from UN agencies (US$) in Singapore in 1971 to that in 1975?
Ensure brevity in your answer.  2.15. What is the ratio of the Aid flow from UN agencies (US$) of Benin in 1972 to that in 1973?
Give a very brief answer. 1.07. What is the ratio of the Aid flow from UN agencies (US$) in Bolivia in 1972 to that in 1973?
Make the answer very short. 0.95. What is the ratio of the Aid flow from UN agencies (US$) of Peru in 1972 to that in 1973?
Your answer should be compact. 0.72. What is the ratio of the Aid flow from UN agencies (US$) of Singapore in 1972 to that in 1973?
Your response must be concise. 1.38. What is the ratio of the Aid flow from UN agencies (US$) of Benin in 1972 to that in 1974?
Offer a terse response. 0.66. What is the ratio of the Aid flow from UN agencies (US$) of Bolivia in 1972 to that in 1974?
Provide a short and direct response. 1.18. What is the ratio of the Aid flow from UN agencies (US$) in Peru in 1972 to that in 1974?
Your answer should be very brief. 0.66. What is the ratio of the Aid flow from UN agencies (US$) of Singapore in 1972 to that in 1974?
Your response must be concise. 2.79. What is the ratio of the Aid flow from UN agencies (US$) in Benin in 1972 to that in 1975?
Your answer should be very brief. 0.28. What is the ratio of the Aid flow from UN agencies (US$) in Bolivia in 1972 to that in 1975?
Your answer should be very brief. 0.89. What is the ratio of the Aid flow from UN agencies (US$) in Peru in 1972 to that in 1975?
Your answer should be very brief. 0.5. What is the ratio of the Aid flow from UN agencies (US$) in Singapore in 1972 to that in 1975?
Offer a very short reply. 2.21. What is the ratio of the Aid flow from UN agencies (US$) in Benin in 1973 to that in 1974?
Offer a terse response. 0.62. What is the ratio of the Aid flow from UN agencies (US$) in Bolivia in 1973 to that in 1974?
Provide a short and direct response. 1.24. What is the ratio of the Aid flow from UN agencies (US$) in Peru in 1973 to that in 1974?
Offer a very short reply. 0.92. What is the ratio of the Aid flow from UN agencies (US$) of Singapore in 1973 to that in 1974?
Offer a terse response. 2.02. What is the ratio of the Aid flow from UN agencies (US$) in Benin in 1973 to that in 1975?
Ensure brevity in your answer.  0.26. What is the ratio of the Aid flow from UN agencies (US$) of Bolivia in 1973 to that in 1975?
Ensure brevity in your answer.  0.94. What is the ratio of the Aid flow from UN agencies (US$) of Peru in 1973 to that in 1975?
Give a very brief answer. 0.7. What is the ratio of the Aid flow from UN agencies (US$) of Benin in 1974 to that in 1975?
Offer a very short reply. 0.42. What is the ratio of the Aid flow from UN agencies (US$) in Bolivia in 1974 to that in 1975?
Make the answer very short. 0.75. What is the ratio of the Aid flow from UN agencies (US$) of Peru in 1974 to that in 1975?
Offer a very short reply. 0.76. What is the ratio of the Aid flow from UN agencies (US$) of Singapore in 1974 to that in 1975?
Provide a short and direct response. 0.79. What is the difference between the highest and the second highest Aid flow from UN agencies (US$) in Benin?
Ensure brevity in your answer.  1.90e+06. What is the difference between the highest and the second highest Aid flow from UN agencies (US$) in Bolivia?
Ensure brevity in your answer.  2.20e+05. What is the difference between the highest and the second highest Aid flow from UN agencies (US$) of Peru?
Offer a terse response. 1.03e+06. What is the difference between the highest and the lowest Aid flow from UN agencies (US$) of Benin?
Your answer should be compact. 2.43e+06. What is the difference between the highest and the lowest Aid flow from UN agencies (US$) in Bolivia?
Ensure brevity in your answer.  1.99e+06. What is the difference between the highest and the lowest Aid flow from UN agencies (US$) in Peru?
Ensure brevity in your answer.  2.16e+06. What is the difference between the highest and the lowest Aid flow from UN agencies (US$) in Singapore?
Offer a very short reply. 1.63e+06. 